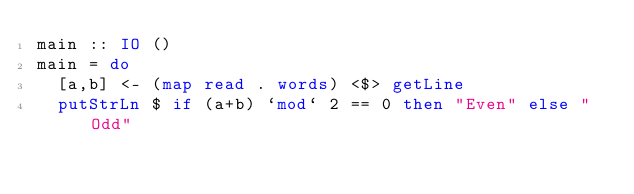<code> <loc_0><loc_0><loc_500><loc_500><_Haskell_>main :: IO ()
main = do
  [a,b] <- (map read . words) <$> getLine
  putStrLn $ if (a+b) `mod` 2 == 0 then "Even" else "Odd"
</code> 